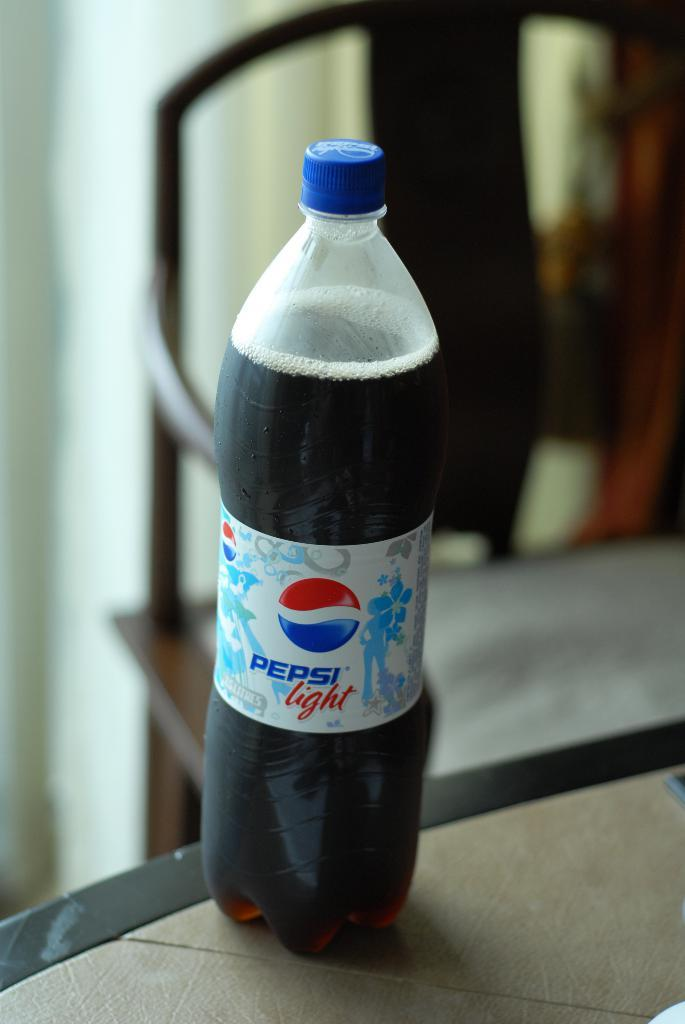What is placed on the table in the image? There is a cool drink bottle placed on a table in the image. Can you describe the setting where the cool drink bottle is located? The cool drink bottle is located on a table, and there is a chair visible in the background of the image. What type of pin is holding the cool drink bottle to the table? There is no pin present in the image; the cool drink bottle is simply placed on the table. 